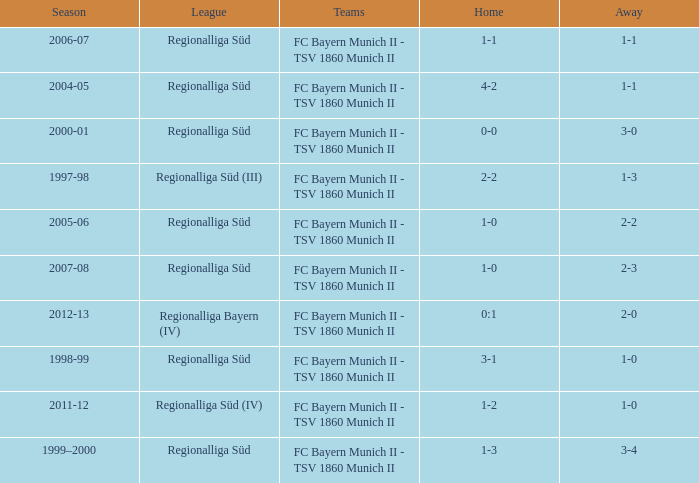What is the home with a 1-1 away in the 2004-05 season? 4-2. 